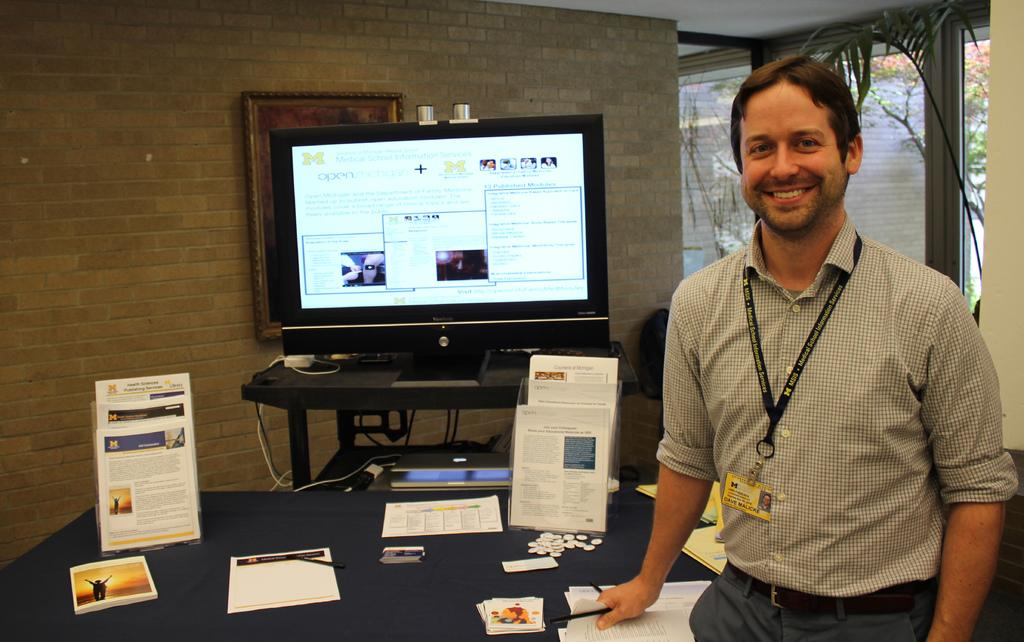What is the man doing in the image? The man is standing in the image. Where is the man positioned in relation to the table? The man is standing in front of a table. What items can be seen on the table? There are books, papers, and a monitor screen on the table. How is the man feeling in the image? The person is laughing, which suggests they are feeling happy or amused. What type of umbrella is the man holding in the image? There is no umbrella present in the image. What year does the system in the image represent? There is no system or specific time period mentioned in the image. 